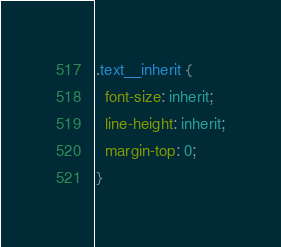Convert code to text. <code><loc_0><loc_0><loc_500><loc_500><_CSS_>
.text__inherit {
  font-size: inherit;
  line-height: inherit;
  margin-top: 0;
}
</code> 